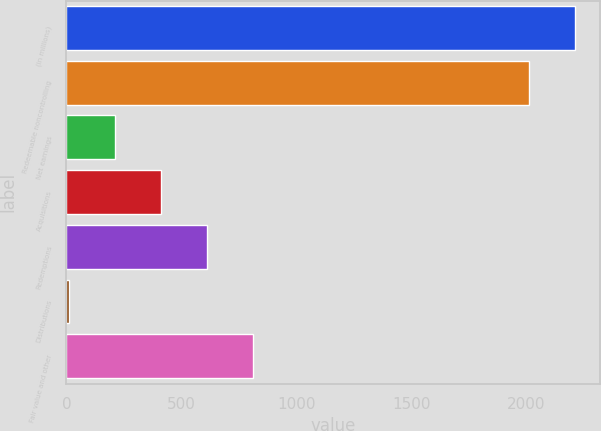Convert chart. <chart><loc_0><loc_0><loc_500><loc_500><bar_chart><fcel>(in millions)<fcel>Redeemable noncontrolling<fcel>Net earnings<fcel>Acquisitions<fcel>Redemptions<fcel>Distributions<fcel>Fair value and other<nl><fcel>2212.5<fcel>2012<fcel>211.5<fcel>412<fcel>612.5<fcel>11<fcel>813<nl></chart> 